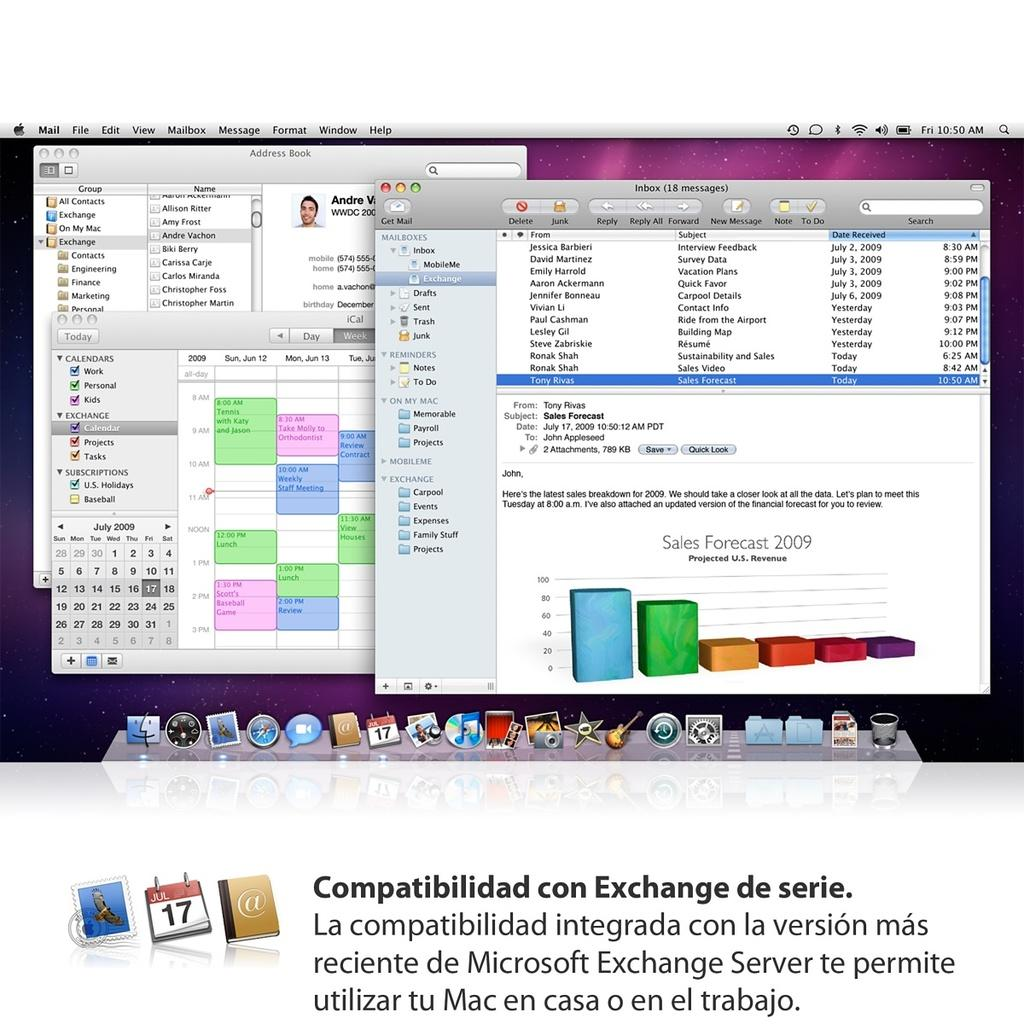<image>
Describe the image concisely. A few windows up on a screen with "Compatibilidad con Exchange de series" written below it. 